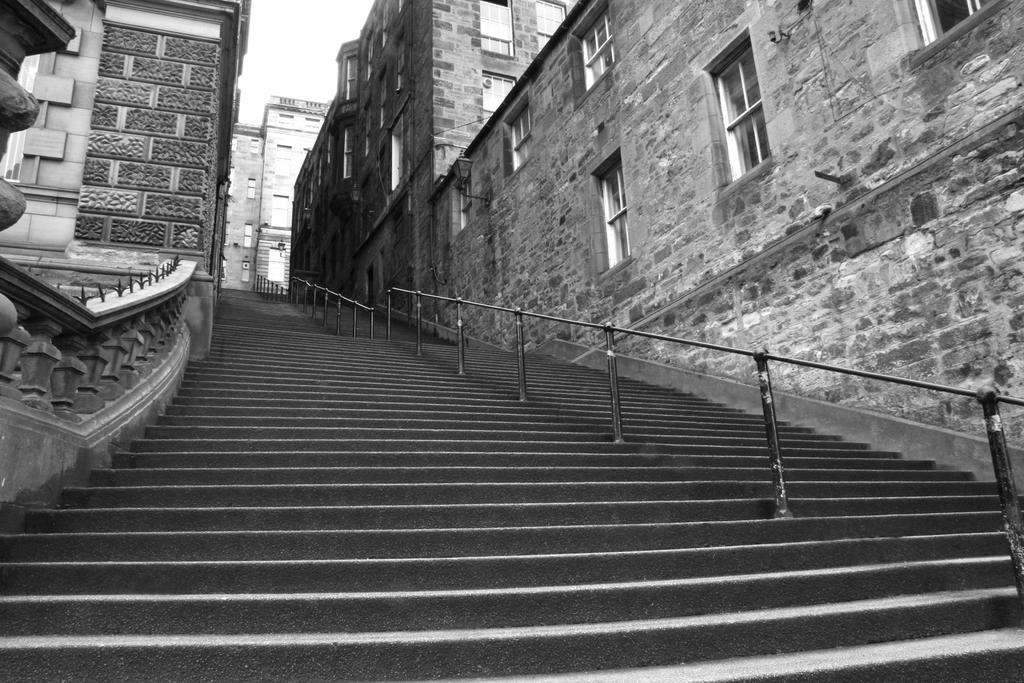What type of structure is present in the image? There is a staircase in the image. What feature does the staircase have? The staircase has a fence. What can be seen in the background of the image? There are buildings in the background of the image. What is visible at the top of the image? The sky is visible at the top of the image. What type of coal distribution system can be seen in the image? There is no coal distribution system present in the image. What color is the gold used to decorate the fence in the image? There is no gold used to decorate the fence in the image; it is not mentioned in the provided facts. 